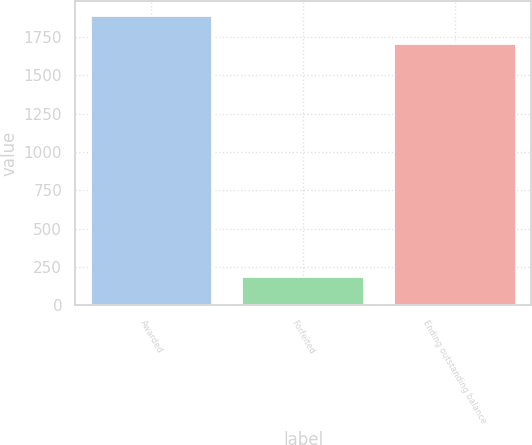<chart> <loc_0><loc_0><loc_500><loc_500><bar_chart><fcel>Awarded<fcel>Forfeited<fcel>Ending outstanding balance<nl><fcel>1891<fcel>184<fcel>1707<nl></chart> 